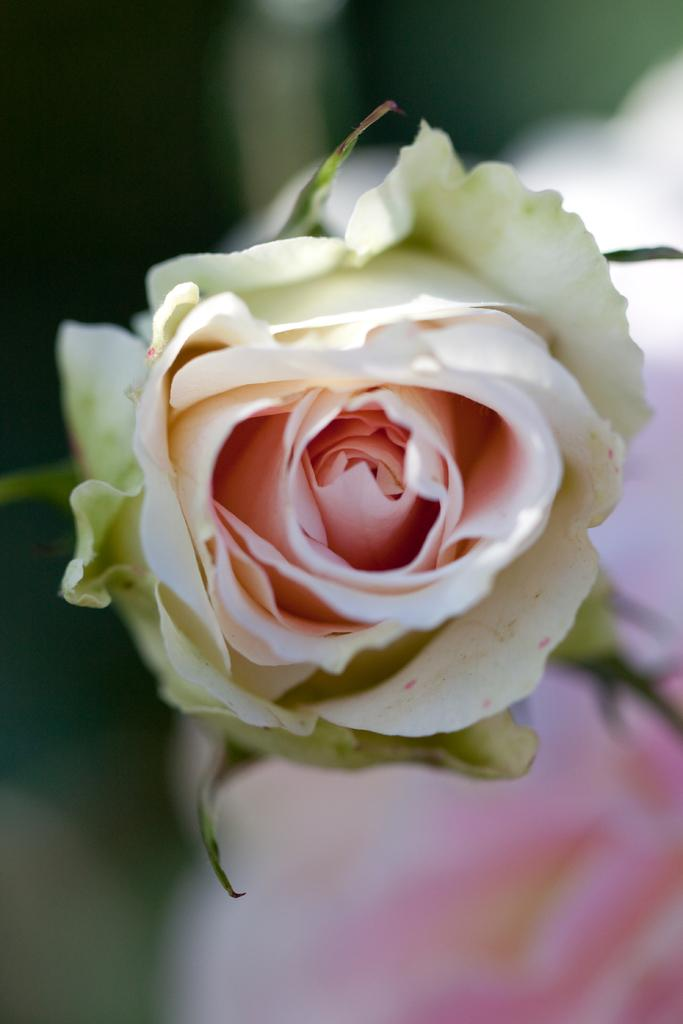What is the main subject of the image? There is a flower in the image. Can you describe the colors of the flower? The flower has white and light pink colors. What can be observed about the background of the image? The background of the image is blurred. Is there a crown visible on the flower in the image? No, there is no crown present on the flower in the image. What type of property does the flower own in the image? The flower is not a living being and therefore cannot own property. 